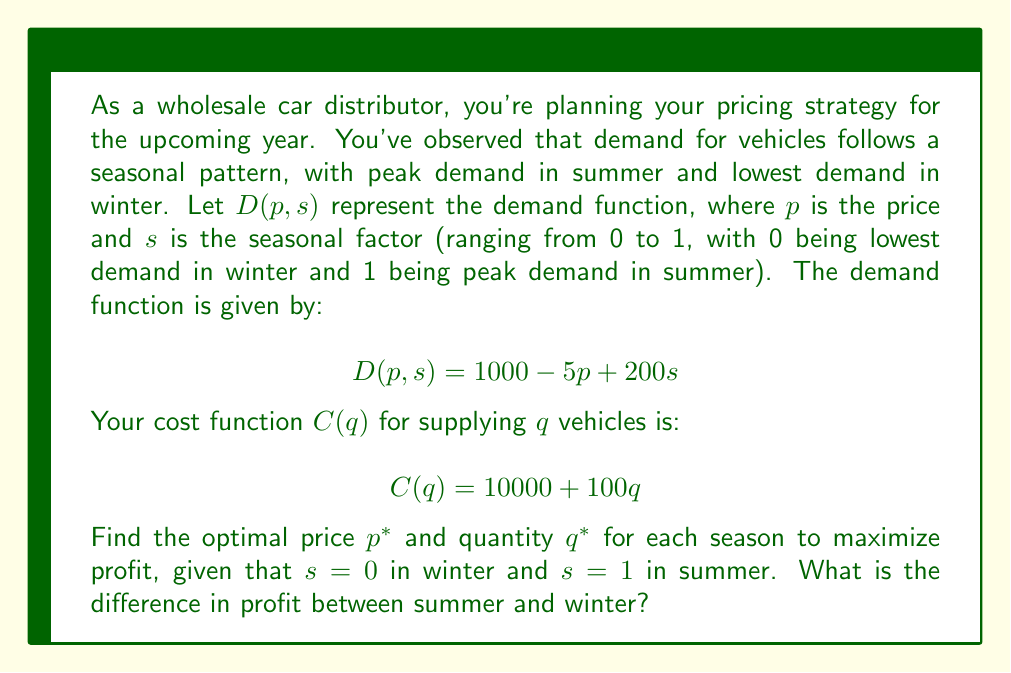Can you solve this math problem? Let's approach this step-by-step:

1) First, we need to set up the profit function. Profit is revenue minus cost:
   $$\Pi(p,s) = pD(p,s) - C(D(p,s))$$

2) Substituting our demand and cost functions:
   $$\Pi(p,s) = p(1000 - 5p + 200s) - [10000 + 100(1000 - 5p + 200s)]$$

3) Expanding this:
   $$\Pi(p,s) = 1000p - 5p^2 + 200ps - 10000 - 100000 + 500p - 20000s$$
   $$\Pi(p,s) = -5p^2 + (1500 + 200s)p - 110000 - 20000s$$

4) To find the optimal price, we differentiate with respect to p and set to zero:
   $$\frac{d\Pi}{dp} = -10p + 1500 + 200s = 0$$

5) Solving for p:
   $$p^* = 150 + 20s$$

6) The optimal quantity q* is found by substituting this price into the demand function:
   $$q^* = D(150 + 20s, s) = 1000 - 5(150 + 20s) + 200s = 250 + 100s$$

7) For Winter (s = 0):
   $p^*_{winter} = 150$, $q^*_{winter} = 250$
   Profit: $\Pi(150, 0) = -5(150)^2 + 1500(150) - 110000 = 27500$

8) For Summer (s = 1):
   $p^*_{summer} = 170$, $q^*_{summer} = 350$
   Profit: $\Pi(170, 1) = -5(170)^2 + 1700(170) - 130000 = 37500$

9) The difference in profit:
   $37500 - 27500 = 10000$
Answer: The optimal price and quantity for Winter (s = 0) are $p^*_{winter} = 150$ and $q^*_{winter} = 250$. For Summer (s = 1), they are $p^*_{summer} = 170$ and $q^*_{summer} = 350$. The difference in profit between summer and winter is $10000. 